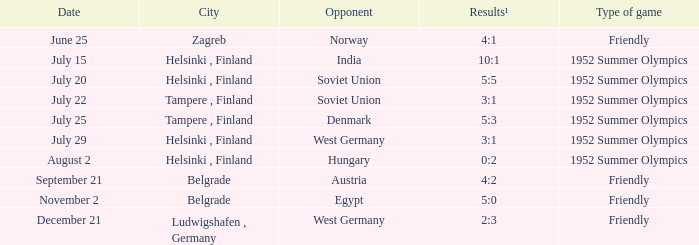On july 29, what kind of game took place? 1952 Summer Olympics. 